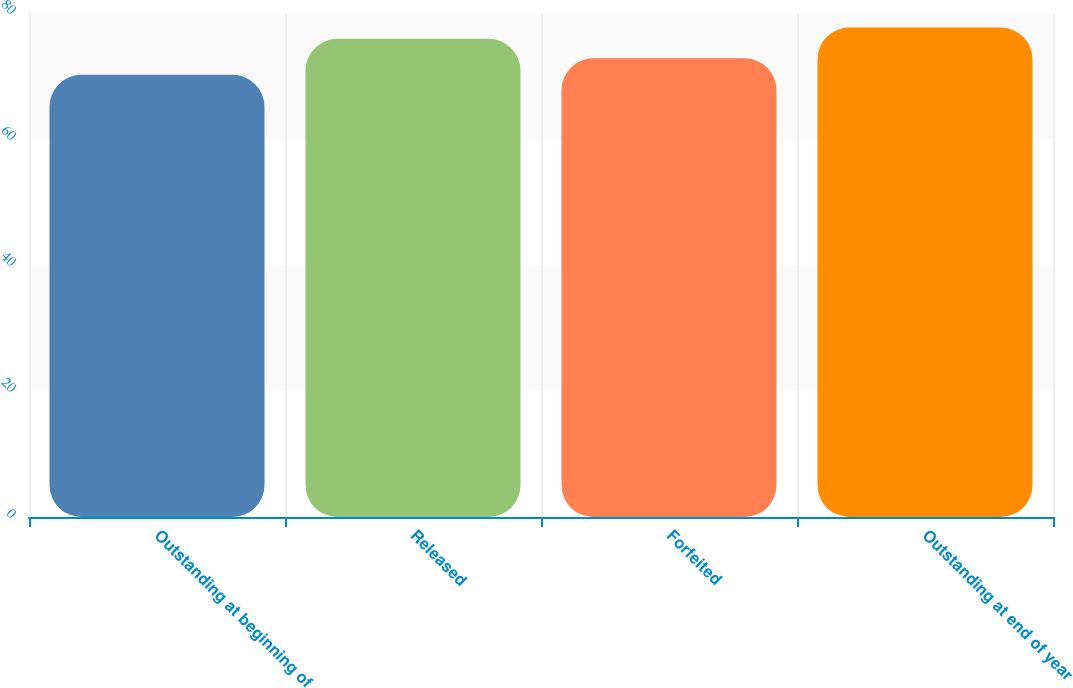<chart> <loc_0><loc_0><loc_500><loc_500><bar_chart><fcel>Outstanding at beginning of<fcel>Released<fcel>Forfeited<fcel>Outstanding at end of year<nl><fcel>70.19<fcel>75.9<fcel>72.81<fcel>77.7<nl></chart> 